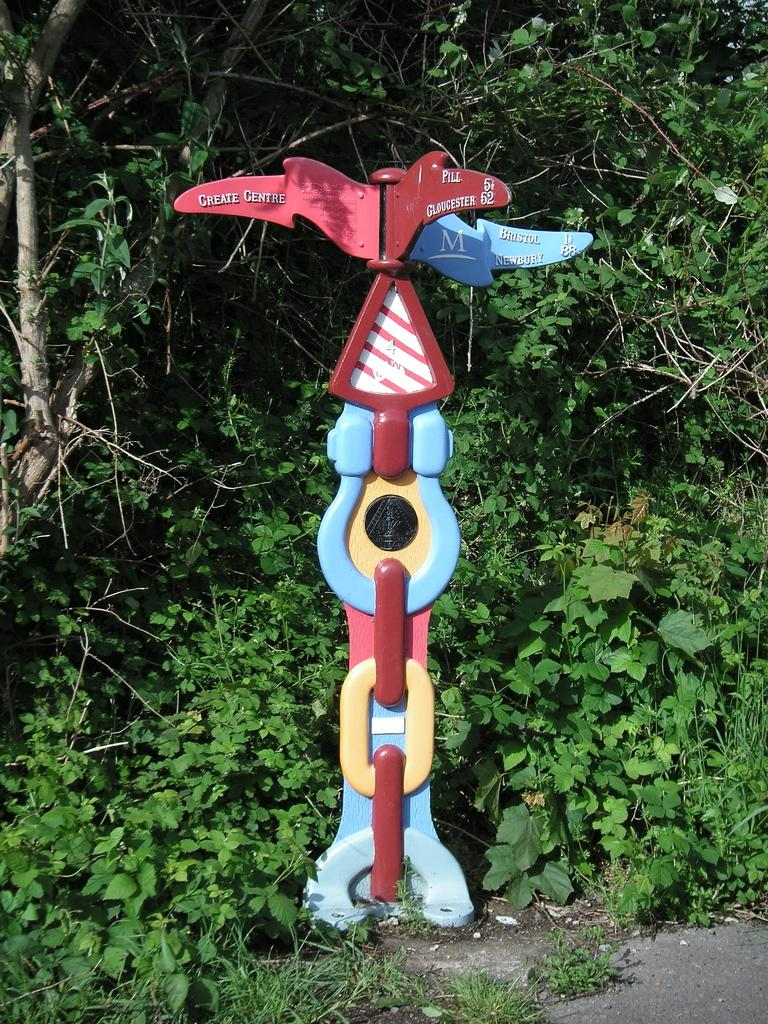What objects are on colorful stands in the image? There are boards on colorful stands in the image. What type of ground surface is visible in the image? There is grass visible in the image. What type of vegetation can be seen in the image? There are plants in the image. What type of interest can be seen on the geese in the image? There are no geese present in the image, so it is not possible to determine what type of interest might be seen on them. 